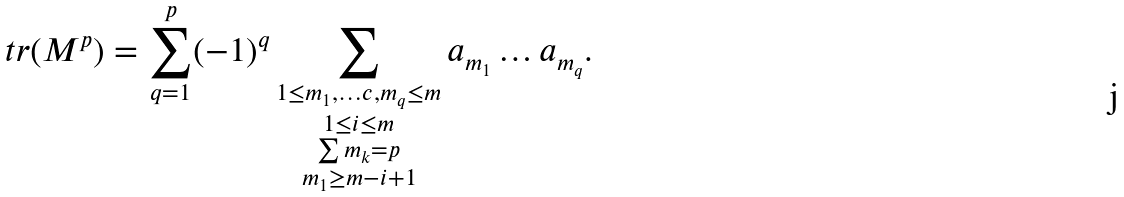Convert formula to latex. <formula><loc_0><loc_0><loc_500><loc_500>\ t r ( M ^ { p } ) = \sum _ { q = 1 } ^ { p } ( - 1 ) ^ { q } \sum _ { \substack { 1 \leq m _ { 1 } , \dots c , m _ { q } \leq m \\ 1 \leq i \leq m \\ \sum m _ { k } = p \\ m _ { 1 } \geq m - i + 1 } } a _ { m _ { 1 } } \dots a _ { m _ { q } } .</formula> 